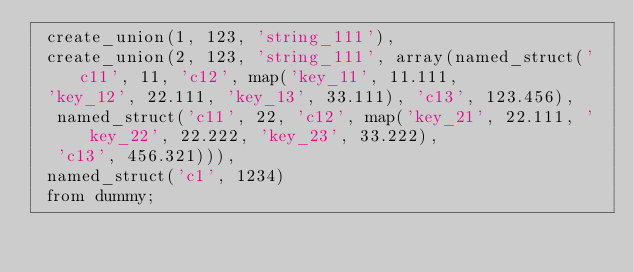Convert code to text. <code><loc_0><loc_0><loc_500><loc_500><_SQL_> create_union(1, 123, 'string_111'),
 create_union(2, 123, 'string_111', array(named_struct('c11', 11, 'c12', map('key_11', 11.111,
 'key_12', 22.111, 'key_13', 33.111), 'c13', 123.456),
  named_struct('c11', 22, 'c12', map('key_21', 22.111, 'key_22', 22.222, 'key_23', 33.222),
  'c13', 456.321))),
 named_struct('c1', 1234)
 from dummy;</code> 